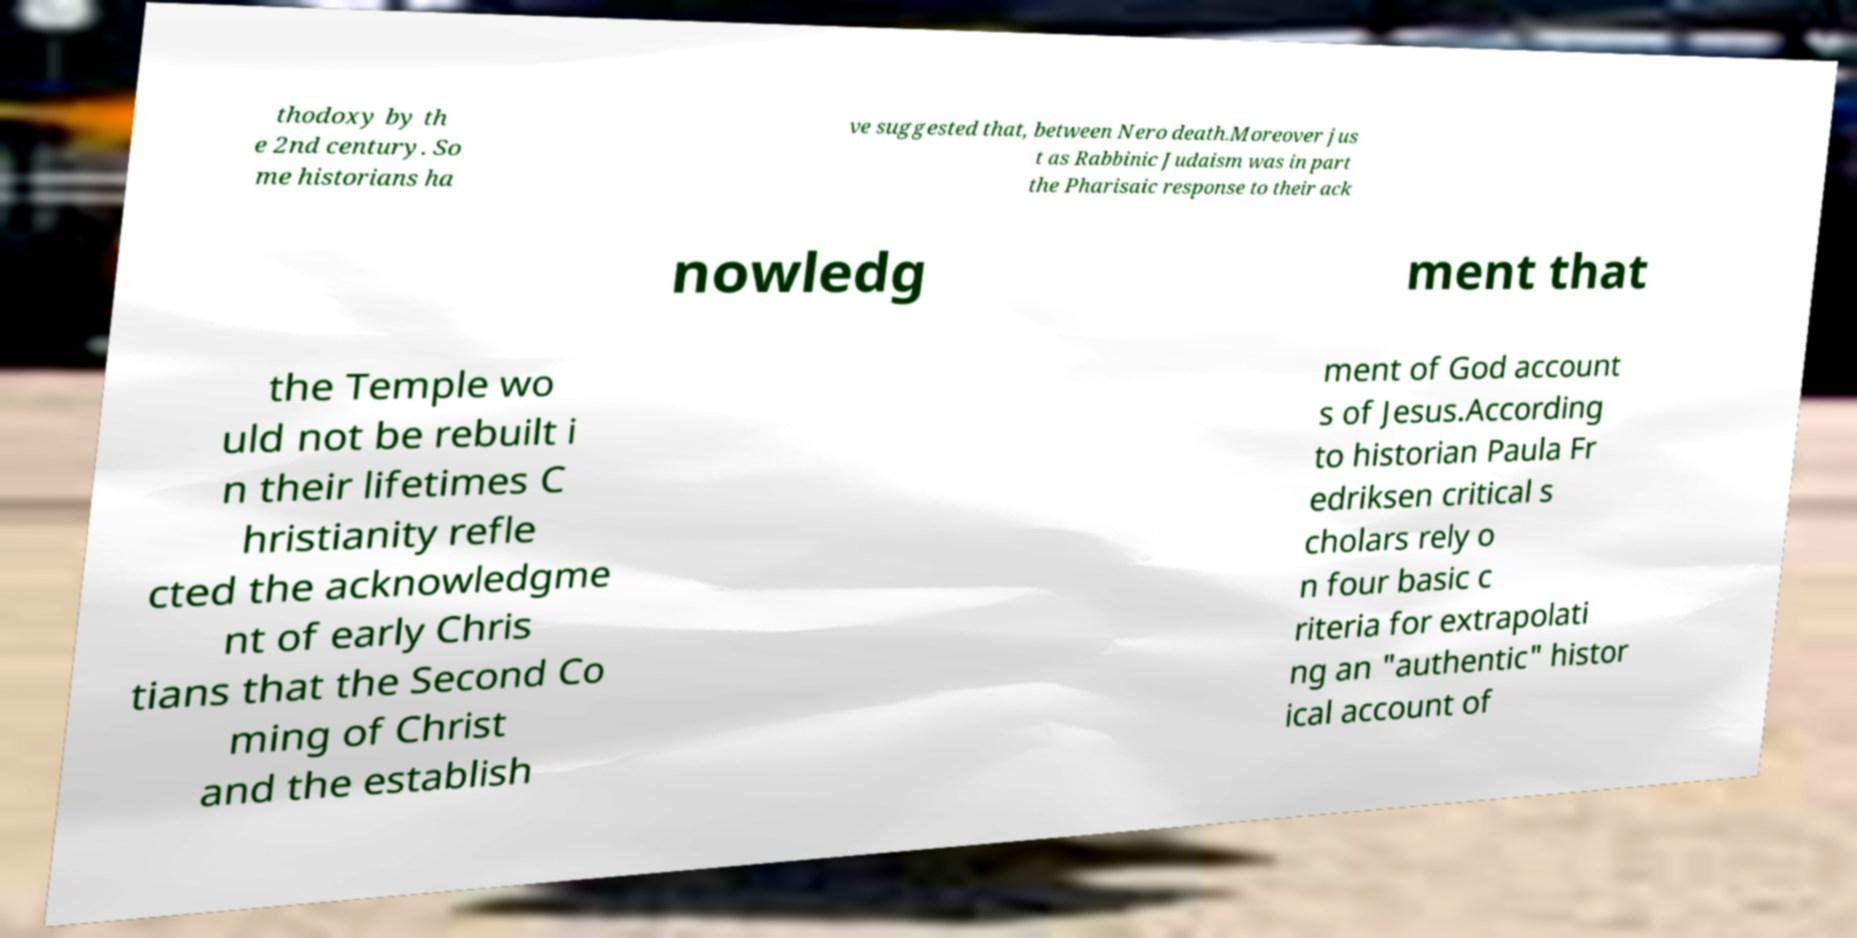Can you read and provide the text displayed in the image?This photo seems to have some interesting text. Can you extract and type it out for me? thodoxy by th e 2nd century. So me historians ha ve suggested that, between Nero death.Moreover jus t as Rabbinic Judaism was in part the Pharisaic response to their ack nowledg ment that the Temple wo uld not be rebuilt i n their lifetimes C hristianity refle cted the acknowledgme nt of early Chris tians that the Second Co ming of Christ and the establish ment of God account s of Jesus.According to historian Paula Fr edriksen critical s cholars rely o n four basic c riteria for extrapolati ng an "authentic" histor ical account of 